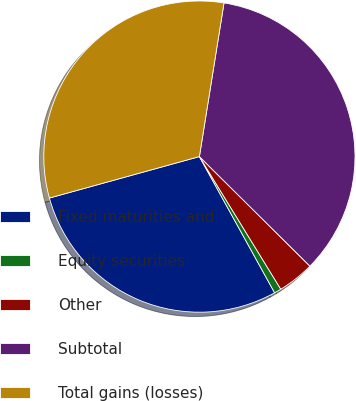<chart> <loc_0><loc_0><loc_500><loc_500><pie_chart><fcel>Fixed maturities and<fcel>Equity securities<fcel>Other<fcel>Subtotal<fcel>Total gains (losses)<nl><fcel>28.74%<fcel>0.73%<fcel>3.81%<fcel>34.9%<fcel>31.82%<nl></chart> 